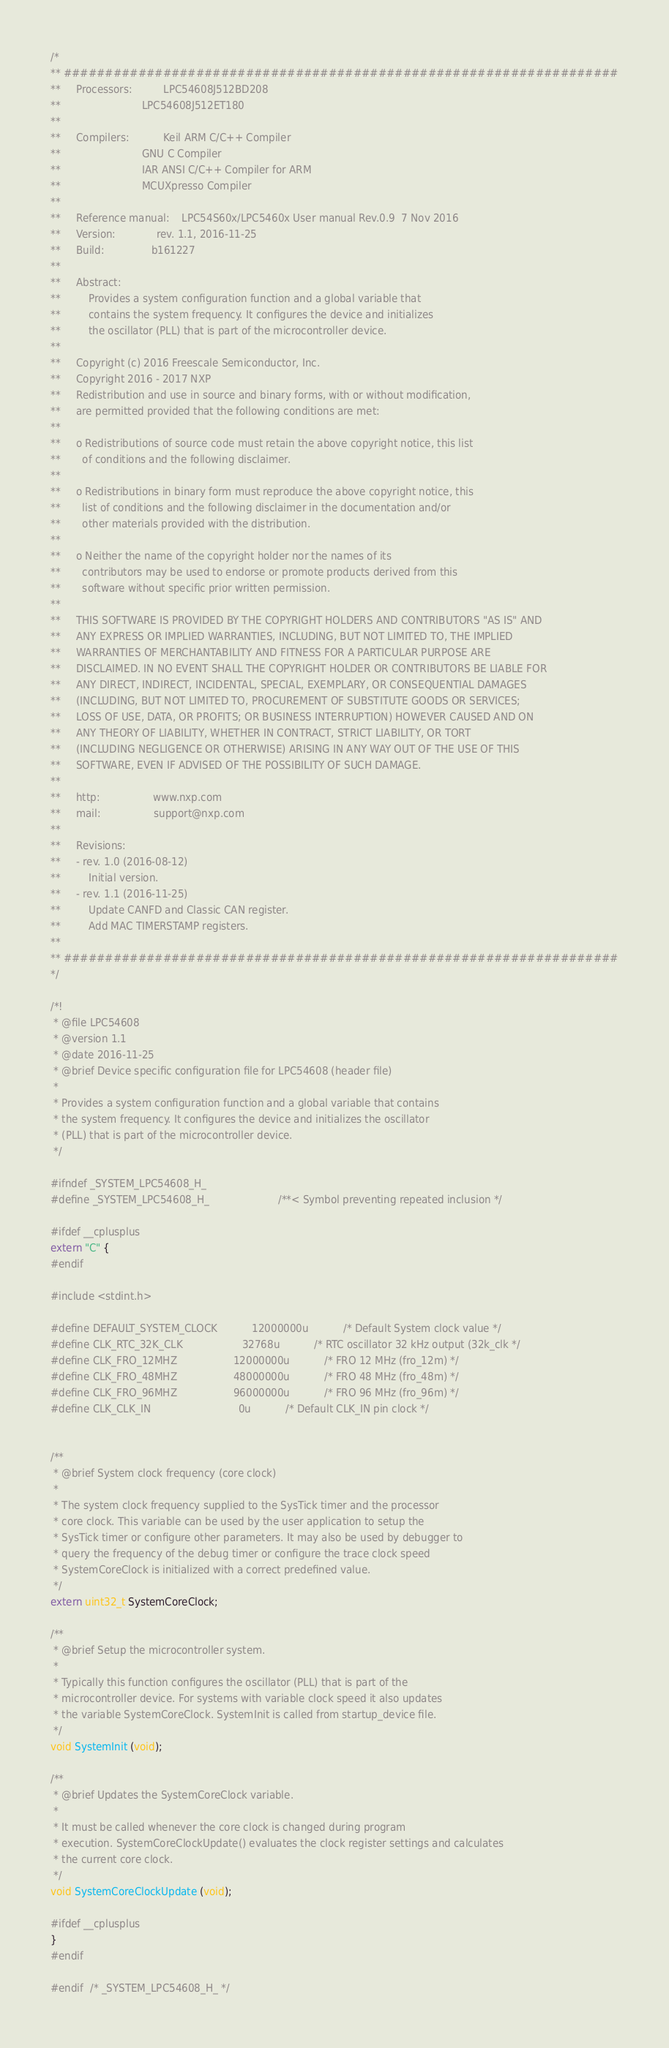Convert code to text. <code><loc_0><loc_0><loc_500><loc_500><_C_>/*
** ###################################################################
**     Processors:          LPC54608J512BD208
**                          LPC54608J512ET180
**
**     Compilers:           Keil ARM C/C++ Compiler
**                          GNU C Compiler
**                          IAR ANSI C/C++ Compiler for ARM
**                          MCUXpresso Compiler
**
**     Reference manual:    LPC54S60x/LPC5460x User manual Rev.0.9  7 Nov 2016
**     Version:             rev. 1.1, 2016-11-25
**     Build:               b161227
**
**     Abstract:
**         Provides a system configuration function and a global variable that
**         contains the system frequency. It configures the device and initializes
**         the oscillator (PLL) that is part of the microcontroller device.
**
**     Copyright (c) 2016 Freescale Semiconductor, Inc.
**     Copyright 2016 - 2017 NXP
**     Redistribution and use in source and binary forms, with or without modification,
**     are permitted provided that the following conditions are met:
**
**     o Redistributions of source code must retain the above copyright notice, this list
**       of conditions and the following disclaimer.
**
**     o Redistributions in binary form must reproduce the above copyright notice, this
**       list of conditions and the following disclaimer in the documentation and/or
**       other materials provided with the distribution.
**
**     o Neither the name of the copyright holder nor the names of its
**       contributors may be used to endorse or promote products derived from this
**       software without specific prior written permission.
**
**     THIS SOFTWARE IS PROVIDED BY THE COPYRIGHT HOLDERS AND CONTRIBUTORS "AS IS" AND
**     ANY EXPRESS OR IMPLIED WARRANTIES, INCLUDING, BUT NOT LIMITED TO, THE IMPLIED
**     WARRANTIES OF MERCHANTABILITY AND FITNESS FOR A PARTICULAR PURPOSE ARE
**     DISCLAIMED. IN NO EVENT SHALL THE COPYRIGHT HOLDER OR CONTRIBUTORS BE LIABLE FOR
**     ANY DIRECT, INDIRECT, INCIDENTAL, SPECIAL, EXEMPLARY, OR CONSEQUENTIAL DAMAGES
**     (INCLUDING, BUT NOT LIMITED TO, PROCUREMENT OF SUBSTITUTE GOODS OR SERVICES;
**     LOSS OF USE, DATA, OR PROFITS; OR BUSINESS INTERRUPTION) HOWEVER CAUSED AND ON
**     ANY THEORY OF LIABILITY, WHETHER IN CONTRACT, STRICT LIABILITY, OR TORT
**     (INCLUDING NEGLIGENCE OR OTHERWISE) ARISING IN ANY WAY OUT OF THE USE OF THIS
**     SOFTWARE, EVEN IF ADVISED OF THE POSSIBILITY OF SUCH DAMAGE.
**
**     http:                 www.nxp.com
**     mail:                 support@nxp.com
**
**     Revisions:
**     - rev. 1.0 (2016-08-12)
**         Initial version.
**     - rev. 1.1 (2016-11-25)
**         Update CANFD and Classic CAN register.
**         Add MAC TIMERSTAMP registers.
**
** ###################################################################
*/

/*!
 * @file LPC54608
 * @version 1.1
 * @date 2016-11-25
 * @brief Device specific configuration file for LPC54608 (header file)
 *
 * Provides a system configuration function and a global variable that contains
 * the system frequency. It configures the device and initializes the oscillator
 * (PLL) that is part of the microcontroller device.
 */

#ifndef _SYSTEM_LPC54608_H_
#define _SYSTEM_LPC54608_H_                      /**< Symbol preventing repeated inclusion */

#ifdef __cplusplus
extern "C" {
#endif

#include <stdint.h>

#define DEFAULT_SYSTEM_CLOCK           12000000u           /* Default System clock value */
#define CLK_RTC_32K_CLK                   32768u           /* RTC oscillator 32 kHz output (32k_clk */
#define CLK_FRO_12MHZ                  12000000u           /* FRO 12 MHz (fro_12m) */
#define CLK_FRO_48MHZ                  48000000u           /* FRO 48 MHz (fro_48m) */
#define CLK_FRO_96MHZ                  96000000u           /* FRO 96 MHz (fro_96m) */
#define CLK_CLK_IN                            0u           /* Default CLK_IN pin clock */


/**
 * @brief System clock frequency (core clock)
 *
 * The system clock frequency supplied to the SysTick timer and the processor
 * core clock. This variable can be used by the user application to setup the
 * SysTick timer or configure other parameters. It may also be used by debugger to
 * query the frequency of the debug timer or configure the trace clock speed
 * SystemCoreClock is initialized with a correct predefined value.
 */
extern uint32_t SystemCoreClock;

/**
 * @brief Setup the microcontroller system.
 *
 * Typically this function configures the oscillator (PLL) that is part of the
 * microcontroller device. For systems with variable clock speed it also updates
 * the variable SystemCoreClock. SystemInit is called from startup_device file.
 */
void SystemInit (void);

/**
 * @brief Updates the SystemCoreClock variable.
 *
 * It must be called whenever the core clock is changed during program
 * execution. SystemCoreClockUpdate() evaluates the clock register settings and calculates
 * the current core clock.
 */
void SystemCoreClockUpdate (void);

#ifdef __cplusplus
}
#endif

#endif  /* _SYSTEM_LPC54608_H_ */
</code> 